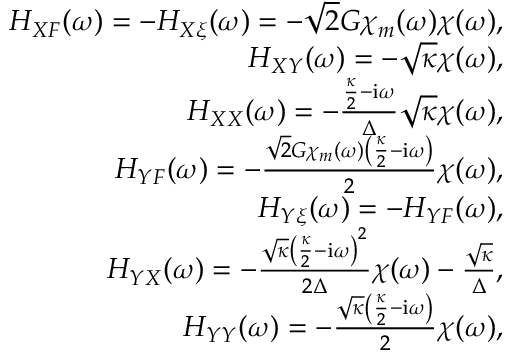Convert formula to latex. <formula><loc_0><loc_0><loc_500><loc_500>\begin{array} { r l r } & { H _ { X F } ( \omega ) = - H _ { X \xi } ( \omega ) = - \sqrt { 2 } G \chi _ { m } ( \omega ) \chi ( \omega ) , } \\ & { H _ { X Y } ( \omega ) = - \sqrt { \kappa } \chi ( \omega ) , } \\ & { H _ { X X } ( \omega ) = - \frac { \frac { \kappa } { 2 } - i \omega } { \Delta } \sqrt { \kappa } \chi ( \omega ) , } \\ & { H _ { Y F } ( \omega ) = - \frac { \sqrt { 2 } G \chi _ { m } ( \omega ) \left ( \frac { \kappa } { 2 } - i \omega \right ) } { 2 } \chi ( \omega ) , } \\ & { H _ { Y \xi } ( \omega ) = - H _ { Y F } ( \omega ) , } \\ & { H _ { Y X } ( \omega ) = - \frac { \sqrt { \kappa } \left ( \frac { \kappa } { 2 } - i \omega \right ) ^ { 2 } } { 2 \Delta } \chi ( \omega ) - \frac { \sqrt { \kappa } } { \Delta } , } \\ & { H _ { Y Y } ( \omega ) = - \frac { \sqrt { \kappa } \left ( \frac { \kappa } { 2 } - i \omega \right ) } { 2 } \chi ( \omega ) , } \end{array}</formula> 